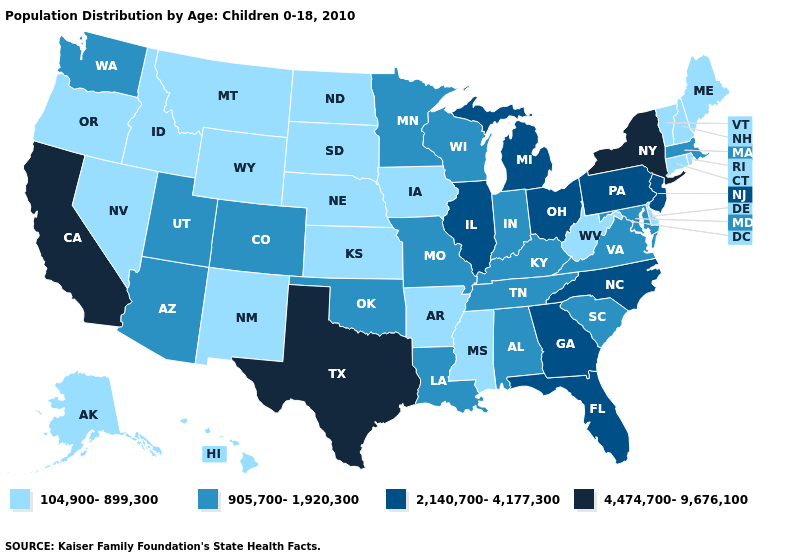Name the states that have a value in the range 4,474,700-9,676,100?
Short answer required. California, New York, Texas. Does California have the highest value in the USA?
Write a very short answer. Yes. What is the value of North Dakota?
Write a very short answer. 104,900-899,300. What is the lowest value in the USA?
Write a very short answer. 104,900-899,300. What is the value of Illinois?
Short answer required. 2,140,700-4,177,300. Is the legend a continuous bar?
Give a very brief answer. No. Which states have the lowest value in the USA?
Quick response, please. Alaska, Arkansas, Connecticut, Delaware, Hawaii, Idaho, Iowa, Kansas, Maine, Mississippi, Montana, Nebraska, Nevada, New Hampshire, New Mexico, North Dakota, Oregon, Rhode Island, South Dakota, Vermont, West Virginia, Wyoming. What is the value of Florida?
Quick response, please. 2,140,700-4,177,300. Does Kentucky have the lowest value in the South?
Concise answer only. No. What is the value of Louisiana?
Write a very short answer. 905,700-1,920,300. Does California have the highest value in the West?
Be succinct. Yes. What is the value of Wyoming?
Short answer required. 104,900-899,300. Does the map have missing data?
Write a very short answer. No. Name the states that have a value in the range 104,900-899,300?
Concise answer only. Alaska, Arkansas, Connecticut, Delaware, Hawaii, Idaho, Iowa, Kansas, Maine, Mississippi, Montana, Nebraska, Nevada, New Hampshire, New Mexico, North Dakota, Oregon, Rhode Island, South Dakota, Vermont, West Virginia, Wyoming. Does New Mexico have the lowest value in the USA?
Concise answer only. Yes. 